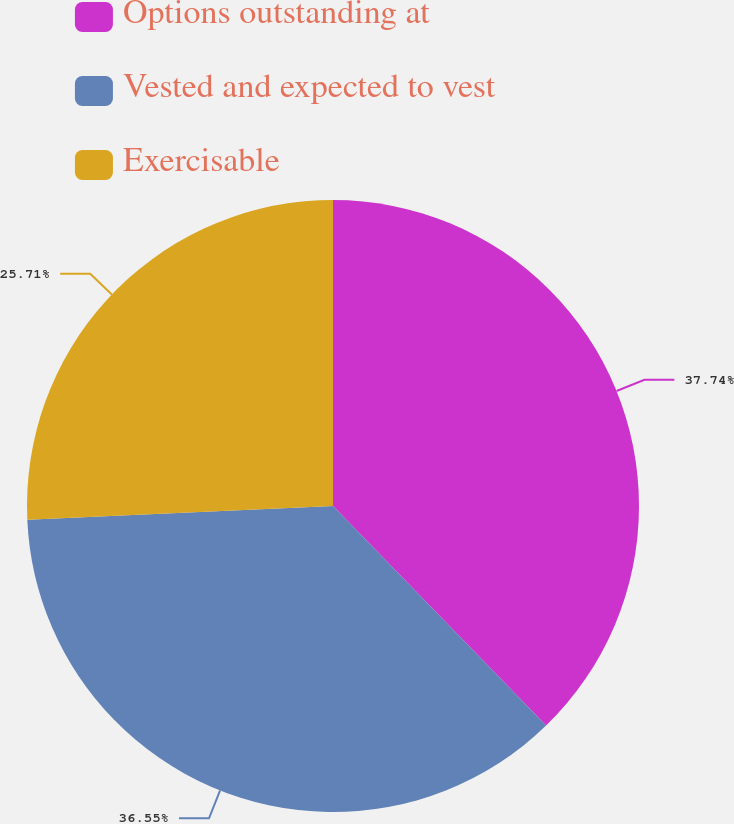Convert chart to OTSL. <chart><loc_0><loc_0><loc_500><loc_500><pie_chart><fcel>Options outstanding at<fcel>Vested and expected to vest<fcel>Exercisable<nl><fcel>37.74%<fcel>36.55%<fcel>25.71%<nl></chart> 